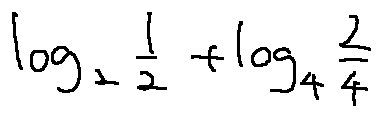Convert formula to latex. <formula><loc_0><loc_0><loc_500><loc_500>\log _ { 2 } \frac { 1 } { 2 } + \log _ { 4 } \frac { 2 } { 4 }</formula> 